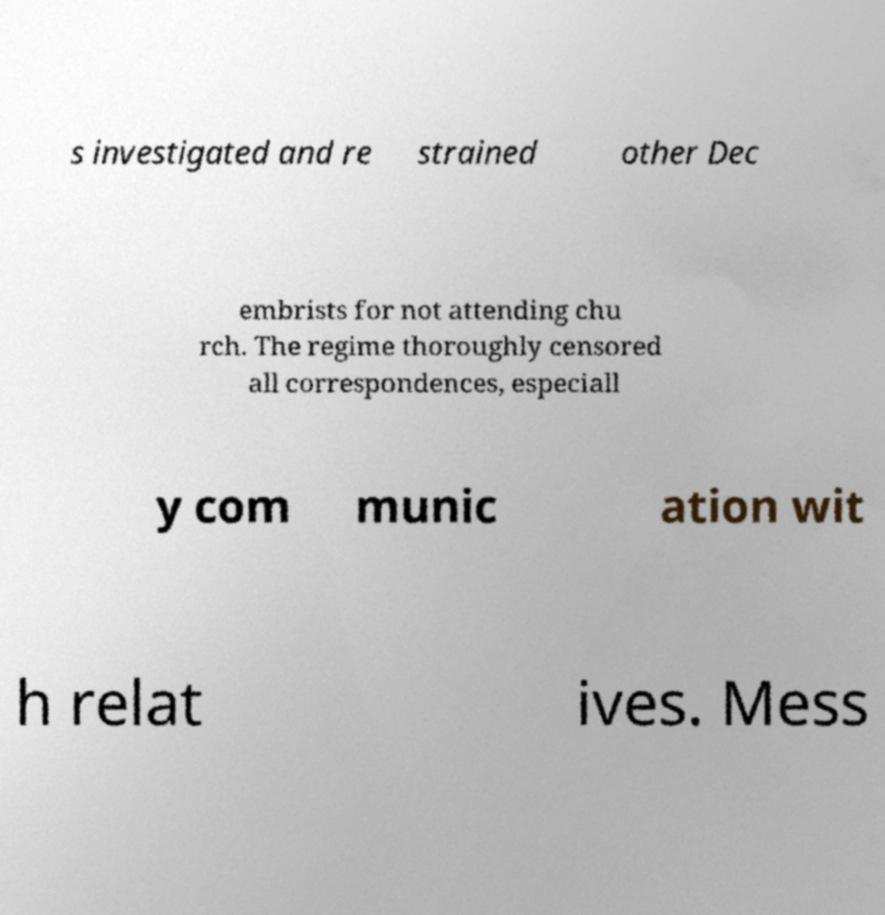For documentation purposes, I need the text within this image transcribed. Could you provide that? s investigated and re strained other Dec embrists for not attending chu rch. The regime thoroughly censored all correspondences, especiall y com munic ation wit h relat ives. Mess 